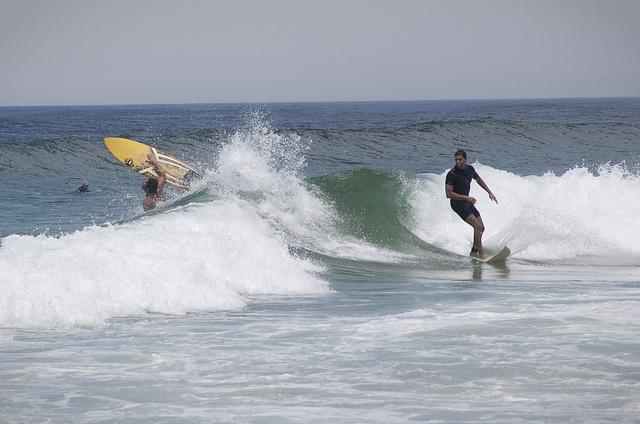Do you see a sea creature in the background?
Quick response, please. No. What color is the man's equipment?
Quick response, please. Yellow. How many surfers are in the water?
Answer briefly. 2. Is the water cold?
Short answer required. Yes. Are waves formed?
Write a very short answer. Yes. Is the person entirely visible?
Keep it brief. Yes. How many surfboards are in this picture?
Be succinct. 2. What color is the surfer's board?
Write a very short answer. Yellow. Does the person have long hair?
Keep it brief. No. Are both of the man's arms in the picture facing straight out?
Write a very short answer. No. What is this person riding?
Answer briefly. Surfboard. How many surfers are there?
Give a very brief answer. 2. What is the number of people?
Short answer required. 2. What are they doing?
Write a very short answer. Surfing. Where are the people surfing?
Give a very brief answer. Ocean. Did the guy fall off the surfboard?
Answer briefly. Yes. How many people are in the water?
Be succinct. 2. How many surfboards are in the water?
Be succinct. 2. What color is the board?
Answer briefly. Yellow. What is the water temperature, based on the man's clothes?
Keep it brief. Warm. Is this a man or a woman surfing?
Quick response, please. Man. Is there anyone else surfing?
Short answer required. Yes. How many people are surfing?
Keep it brief. 2. What colors are on the board?
Write a very short answer. Yellow and white. What color is the surfboard?
Give a very brief answer. Yellow. Does this person have a row?
Short answer required. No. Is the man still in contact with his surfboard?
Answer briefly. Yes. 